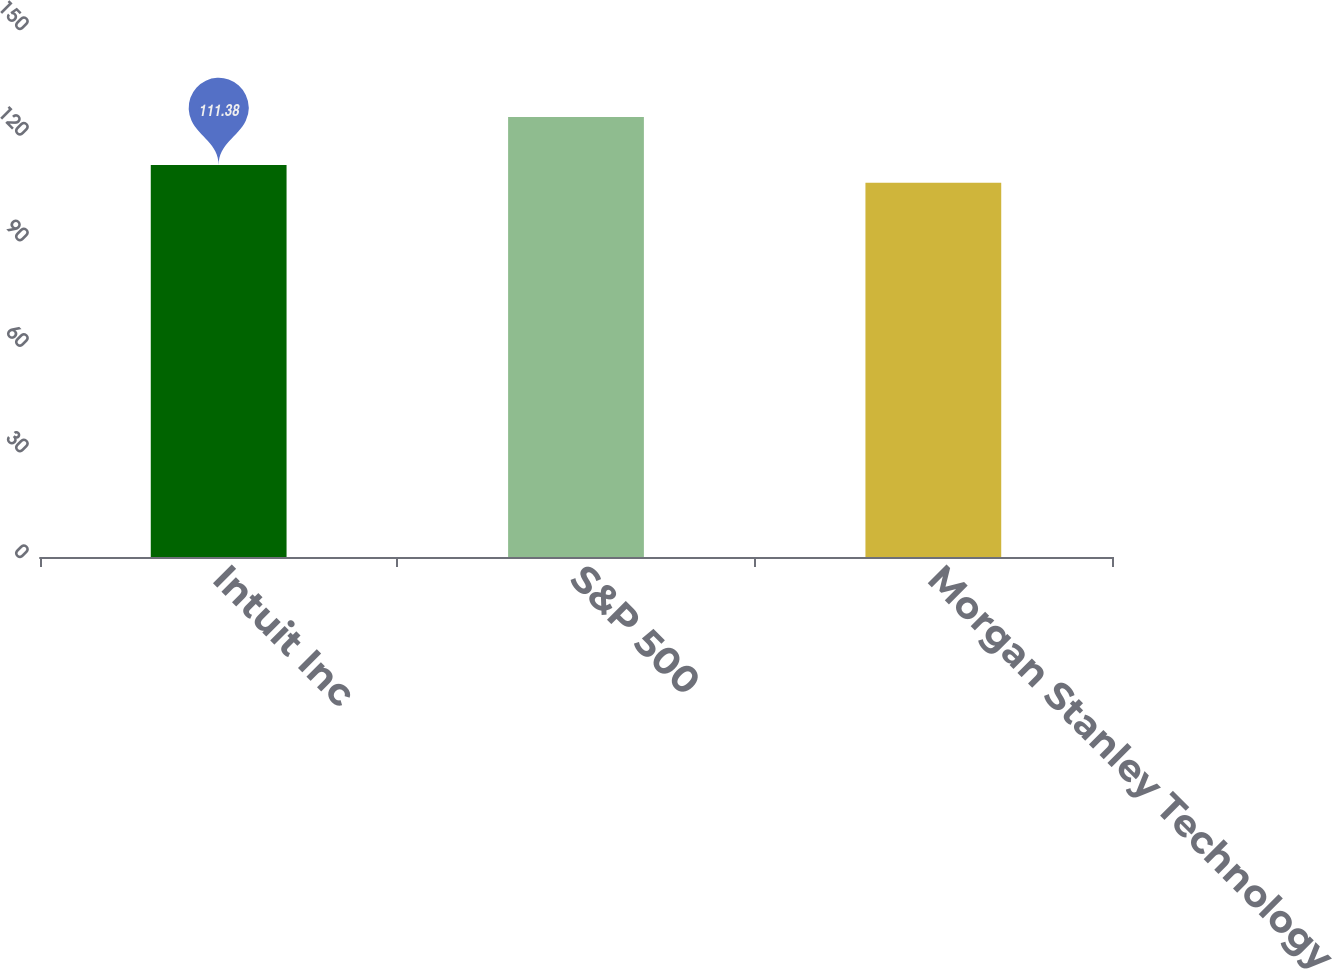Convert chart to OTSL. <chart><loc_0><loc_0><loc_500><loc_500><bar_chart><fcel>Intuit Inc<fcel>S&P 500<fcel>Morgan Stanley Technology<nl><fcel>111.38<fcel>125<fcel>106.35<nl></chart> 